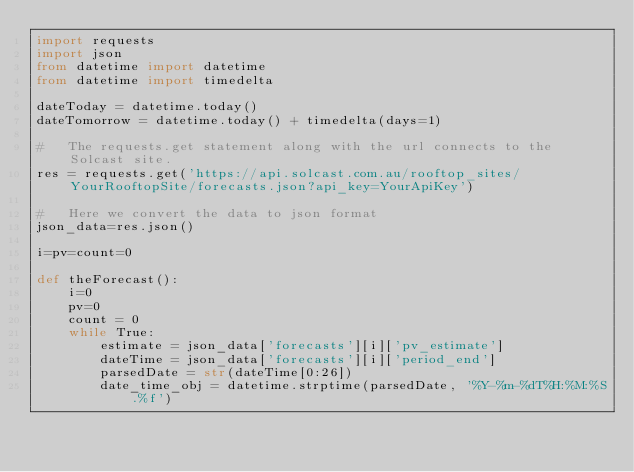Convert code to text. <code><loc_0><loc_0><loc_500><loc_500><_Python_>import requests
import json
from datetime import datetime
from datetime import timedelta

dateToday = datetime.today()
dateTomorrow = datetime.today() + timedelta(days=1)

#   The requests.get statement along with the url connects to the Solcast site.
res = requests.get('https://api.solcast.com.au/rooftop_sites/YourRooftopSite/forecasts.json?api_key=YourApiKey')

#   Here we convert the data to json format
json_data=res.json()

i=pv=count=0

def theForecast():
    i=0
    pv=0
    count = 0
    while True:
        estimate = json_data['forecasts'][i]['pv_estimate']
        dateTime = json_data['forecasts'][i]['period_end']
        parsedDate = str(dateTime[0:26])
        date_time_obj = datetime.strptime(parsedDate, '%Y-%m-%dT%H:%M:%S.%f')</code> 